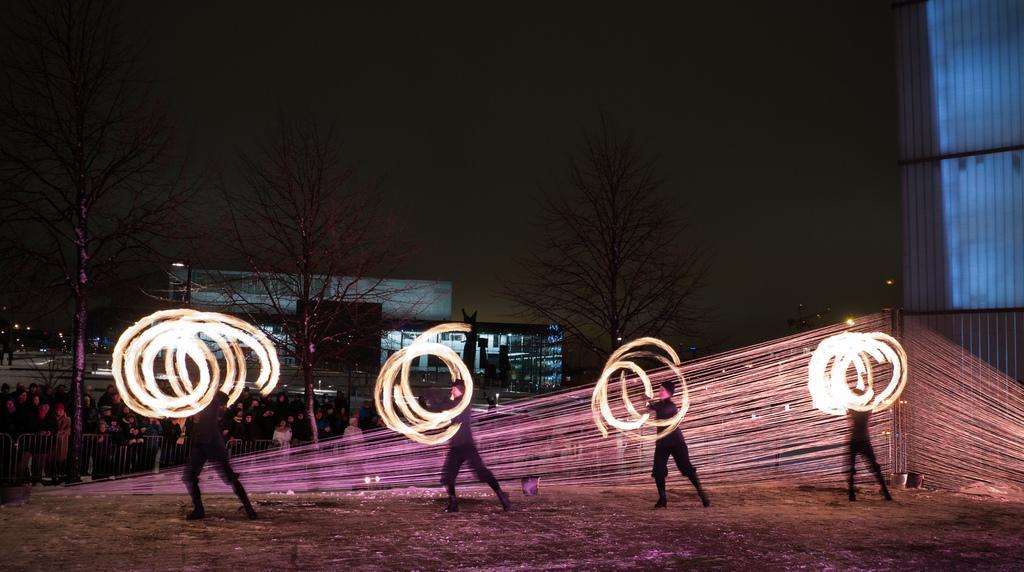Could you give a brief overview of what you see in this image? In the foreground of the picture we can see people, soil, cables, pole, buckets and other objects. The people are doing something we can see light around them. Towards left in the middle there are trees, people, railing, buildings and other objects. On the right there is a building. At the top it is sky. 